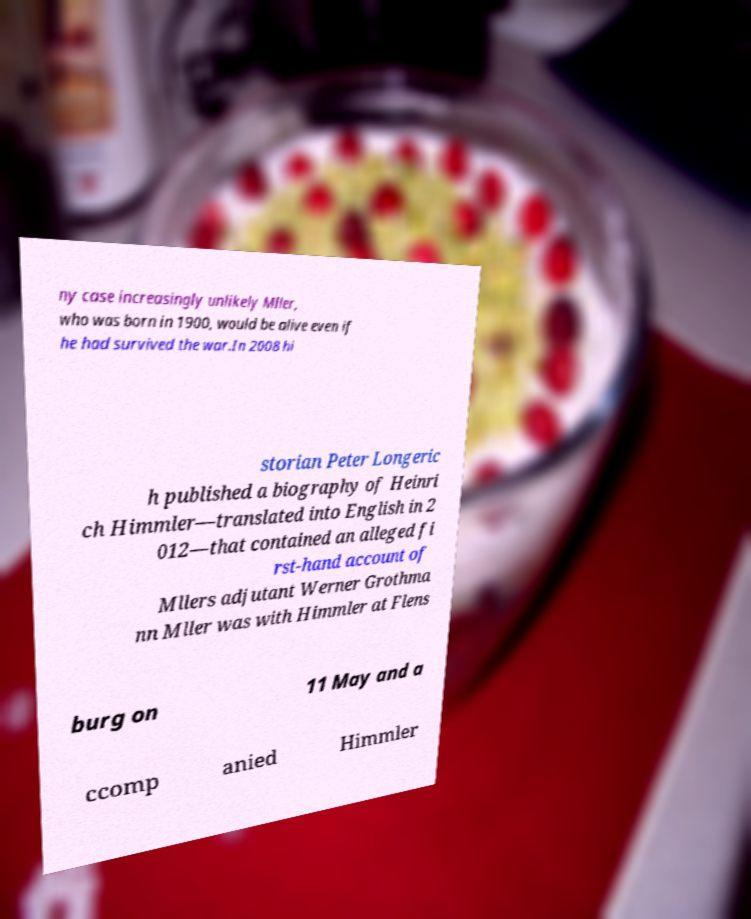Can you read and provide the text displayed in the image?This photo seems to have some interesting text. Can you extract and type it out for me? ny case increasingly unlikely Mller, who was born in 1900, would be alive even if he had survived the war.In 2008 hi storian Peter Longeric h published a biography of Heinri ch Himmler—translated into English in 2 012—that contained an alleged fi rst-hand account of Mllers adjutant Werner Grothma nn Mller was with Himmler at Flens burg on 11 May and a ccomp anied Himmler 